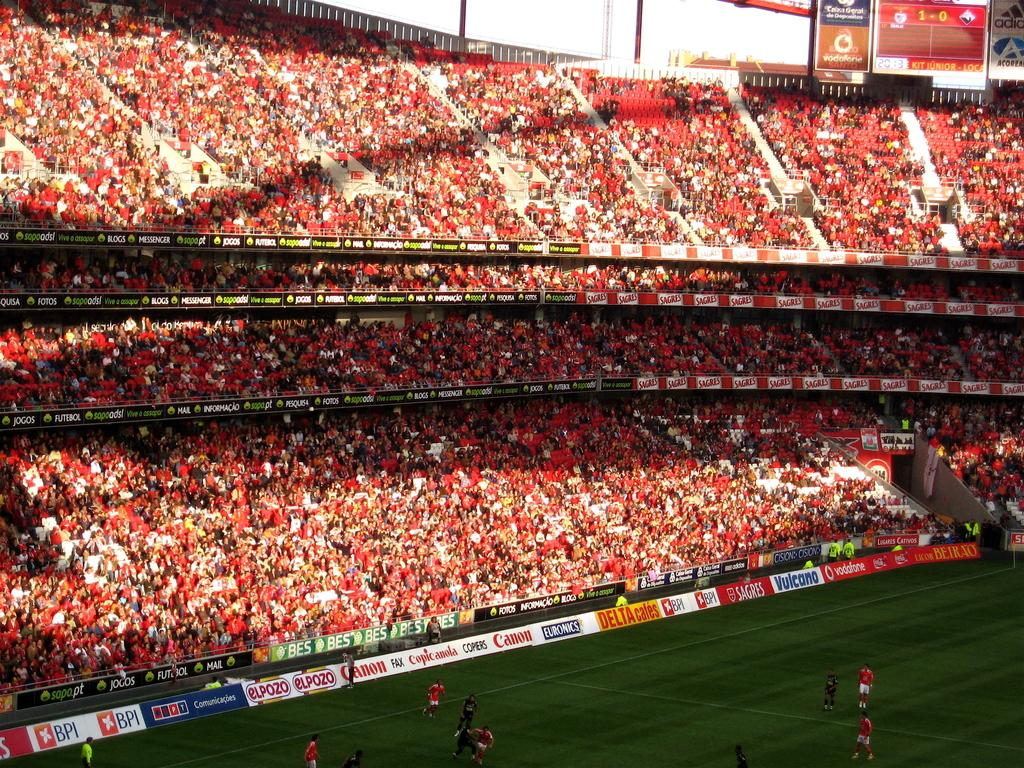<image>
Write a terse but informative summary of the picture. Canon is one of the sponsors of this large stadium with red seats. 